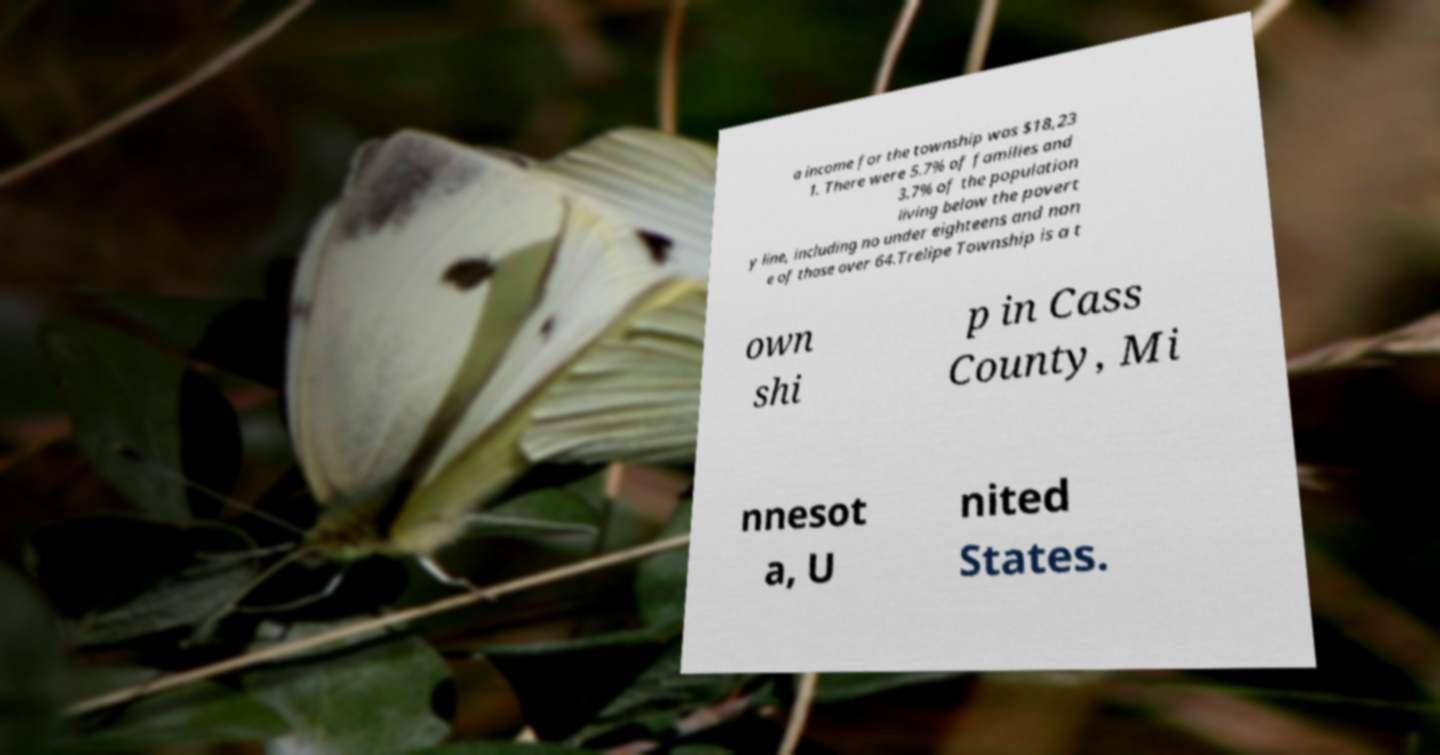Can you read and provide the text displayed in the image?This photo seems to have some interesting text. Can you extract and type it out for me? a income for the township was $18,23 1. There were 5.7% of families and 3.7% of the population living below the povert y line, including no under eighteens and non e of those over 64.Trelipe Township is a t own shi p in Cass County, Mi nnesot a, U nited States. 